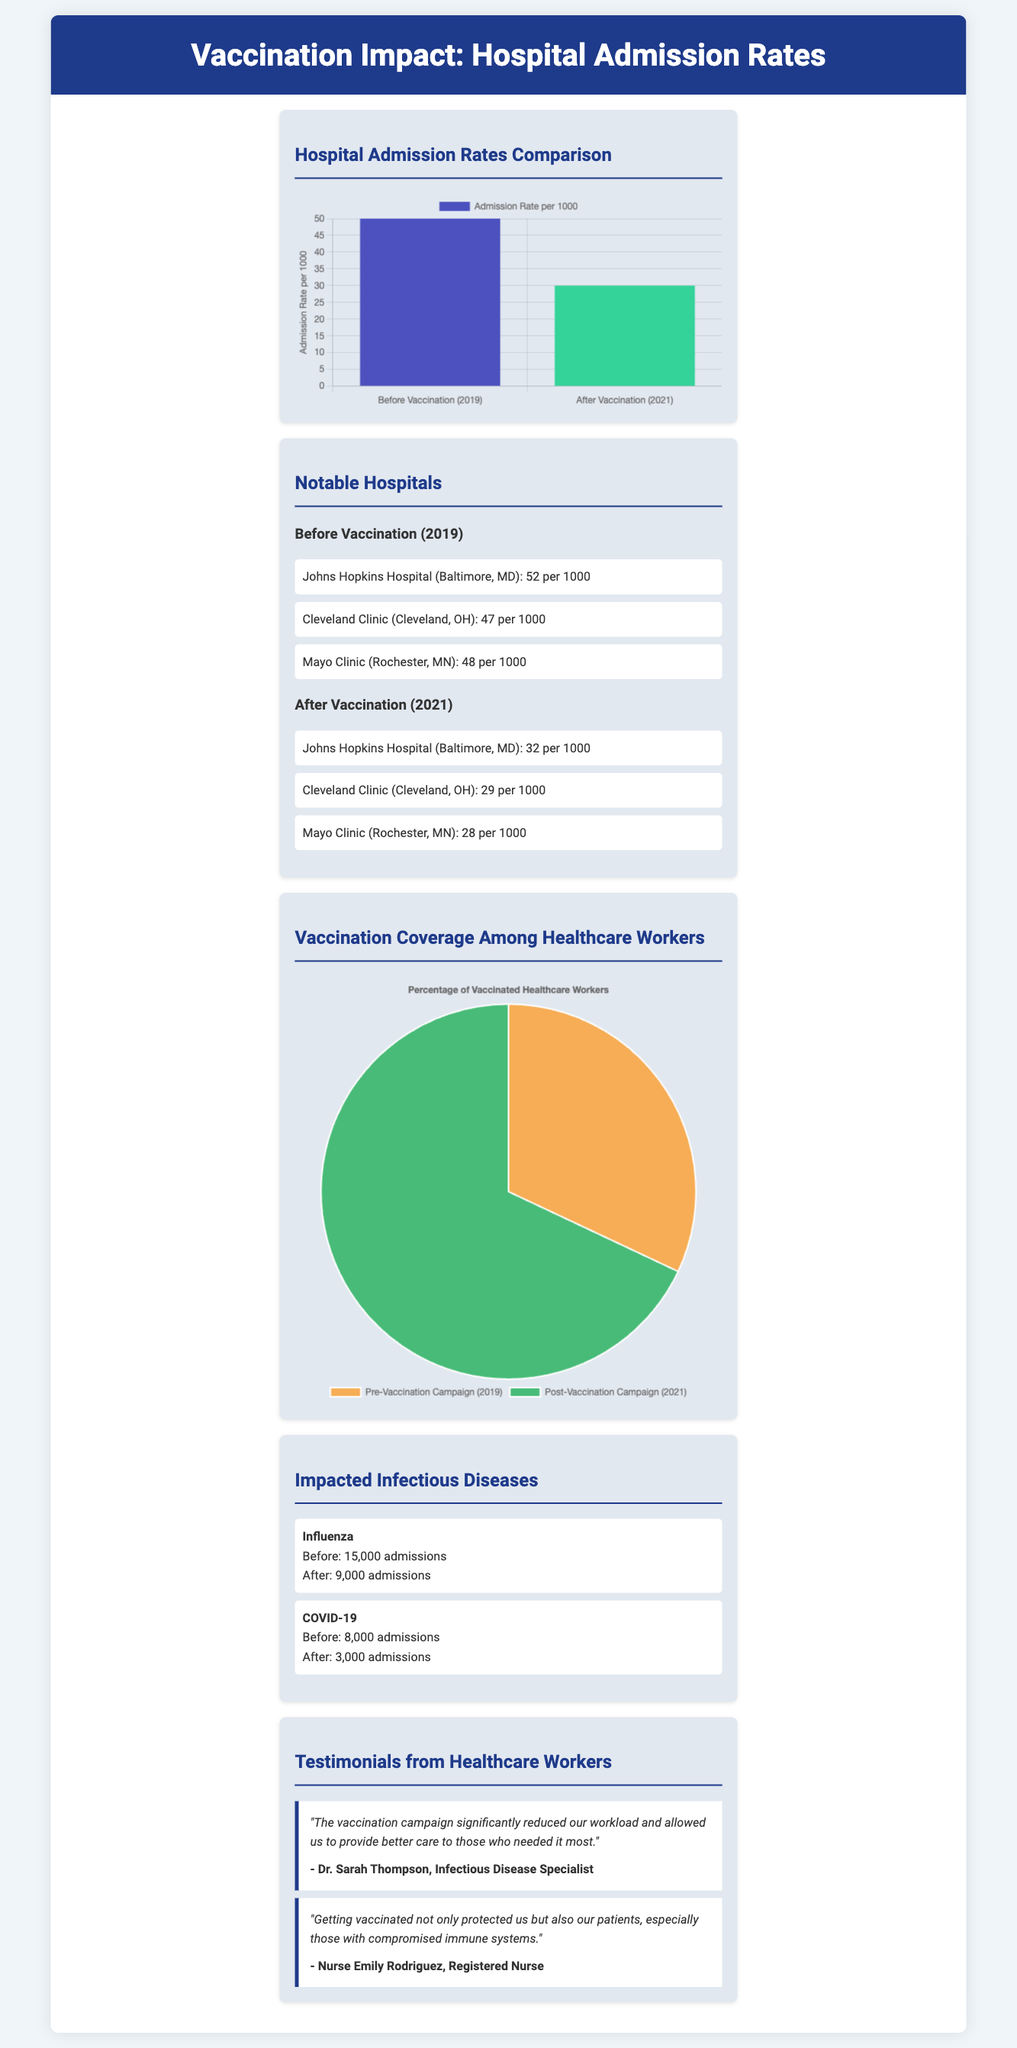what was the admission rate for Johns Hopkins Hospital before vaccination? The document states that the admission rate for Johns Hopkins Hospital before vaccination was 52 per 1000.
Answer: 52 per 1000 what is the admission rate for Cleveland Clinic after vaccination? The document shows that the admission rate for Cleveland Clinic after vaccination was 29 per 1000.
Answer: 29 per 1000 how many admissions for COVID-19 were reported after vaccination? The document indicates that after vaccination, there were 3,000 admissions for COVID-19.
Answer: 3,000 admissions what percentage of healthcare workers were vaccinated after the campaign? The document states that 85% of healthcare workers were vaccinated after the campaign.
Answer: 85% which infectious disease saw a decrease in admissions from 15,000 to 9,000? The document notes that influenza saw a decrease in admissions from 15,000 to 9,000.
Answer: Influenza which hospital had the lowest admission rate after vaccination? According to the document, Mayo Clinic had the lowest admission rate after vaccination, at 28 per 1000.
Answer: Mayo Clinic what was the vaccination percentage before the campaign? The document mentions that the vaccination percentage before the campaign was 40%.
Answer: 40% who stated that the vaccination campaign reduced their workload? The document quotes Dr. Sarah Thompson, an Infectious Disease Specialist, as saying the campaign reduced their workload.
Answer: Dr. Sarah Thompson how many admissions for influenza were reported before vaccination? The document indicates that there were 15,000 admissions for influenza before vaccination.
Answer: 15,000 admissions 